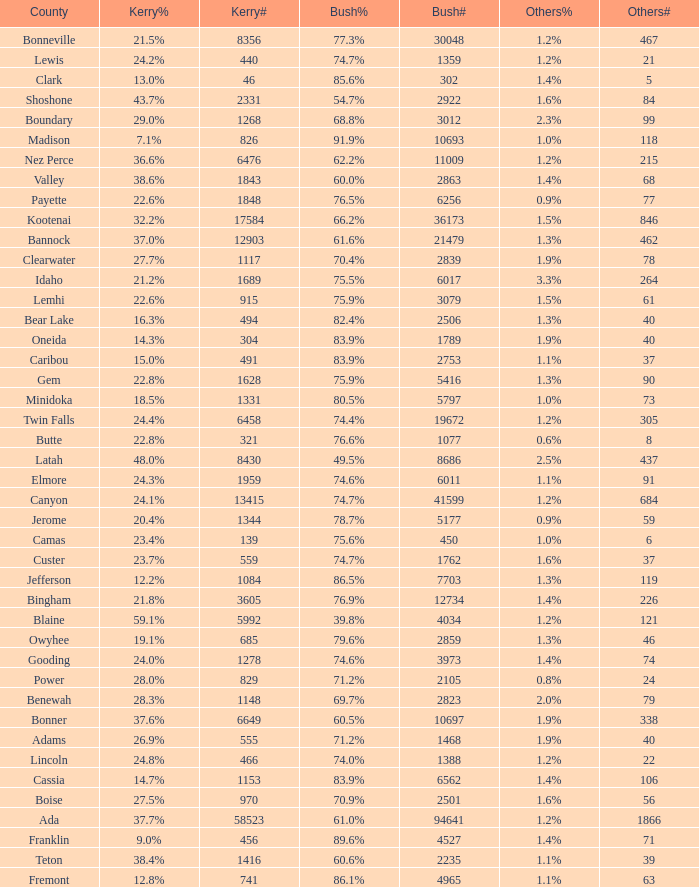What percentage of the votes were for others in the county where 462 people voted that way? 1.3%. 